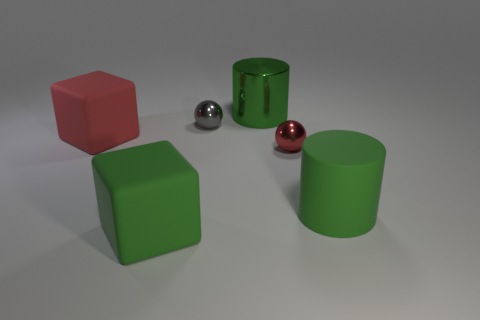Which object appears to be the smallest, and what color is it? The smallest object is the sphere on the right, which has a reflective pink hue. Is there a reason the pink sphere looks shinier than the other objects? The shininess of the pink sphere is likely due to its smooth surface which reflects light more clearly, indicating it may be made of a different material or have been treated to have a glossier finish. 